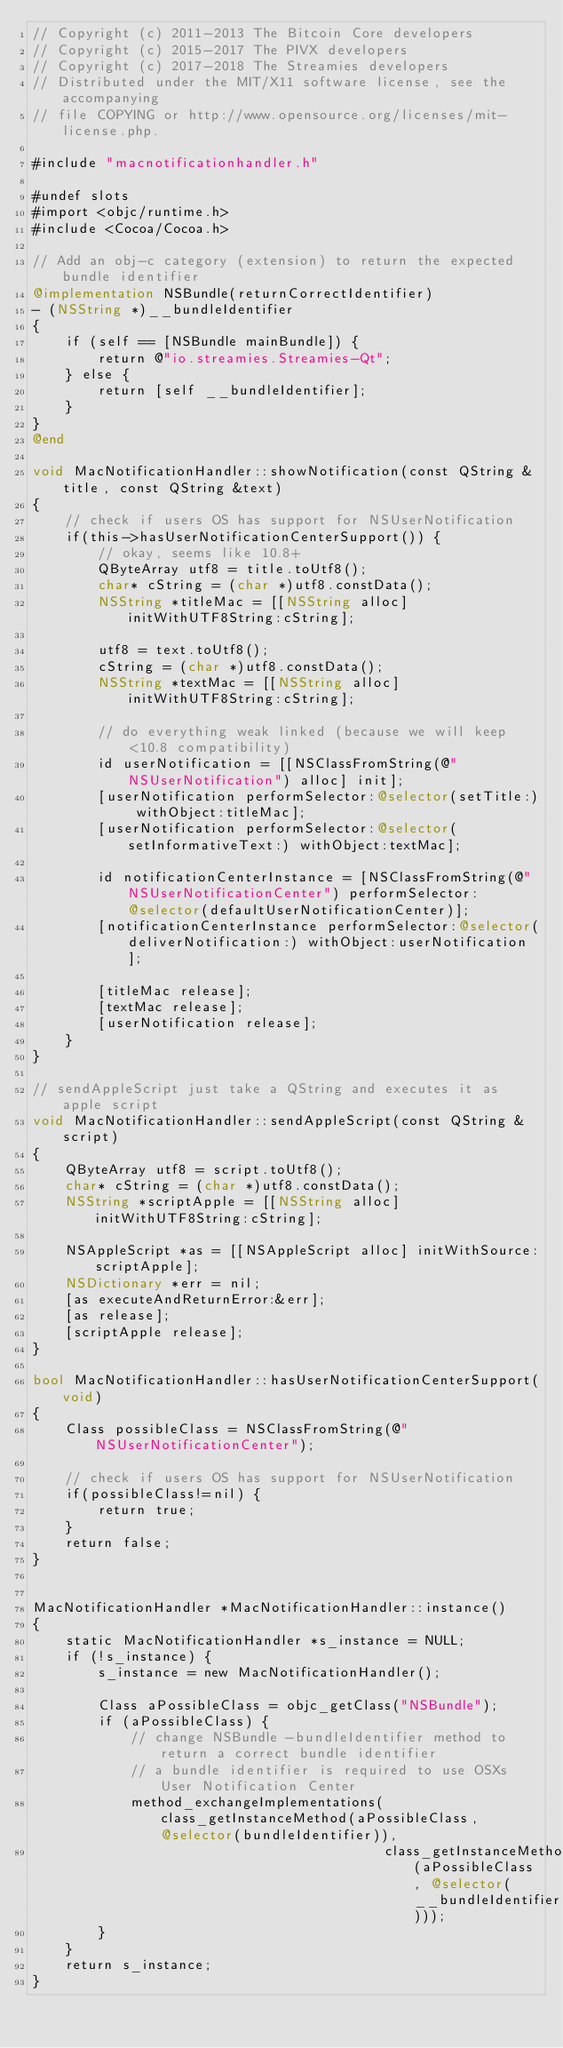<code> <loc_0><loc_0><loc_500><loc_500><_ObjectiveC_>// Copyright (c) 2011-2013 The Bitcoin Core developers
// Copyright (c) 2015-2017 The PIVX developers
// Copyright (c) 2017-2018 The Streamies developers
// Distributed under the MIT/X11 software license, see the accompanying
// file COPYING or http://www.opensource.org/licenses/mit-license.php.

#include "macnotificationhandler.h"

#undef slots
#import <objc/runtime.h>
#include <Cocoa/Cocoa.h>

// Add an obj-c category (extension) to return the expected bundle identifier
@implementation NSBundle(returnCorrectIdentifier)
- (NSString *)__bundleIdentifier
{
    if (self == [NSBundle mainBundle]) {
        return @"io.streamies.Streamies-Qt";
    } else {
        return [self __bundleIdentifier];
    }
}
@end

void MacNotificationHandler::showNotification(const QString &title, const QString &text)
{
    // check if users OS has support for NSUserNotification
    if(this->hasUserNotificationCenterSupport()) {
        // okay, seems like 10.8+
        QByteArray utf8 = title.toUtf8();
        char* cString = (char *)utf8.constData();
        NSString *titleMac = [[NSString alloc] initWithUTF8String:cString];

        utf8 = text.toUtf8();
        cString = (char *)utf8.constData();
        NSString *textMac = [[NSString alloc] initWithUTF8String:cString];

        // do everything weak linked (because we will keep <10.8 compatibility)
        id userNotification = [[NSClassFromString(@"NSUserNotification") alloc] init];
        [userNotification performSelector:@selector(setTitle:) withObject:titleMac];
        [userNotification performSelector:@selector(setInformativeText:) withObject:textMac];

        id notificationCenterInstance = [NSClassFromString(@"NSUserNotificationCenter") performSelector:@selector(defaultUserNotificationCenter)];
        [notificationCenterInstance performSelector:@selector(deliverNotification:) withObject:userNotification];

        [titleMac release];
        [textMac release];
        [userNotification release];
    }
}

// sendAppleScript just take a QString and executes it as apple script
void MacNotificationHandler::sendAppleScript(const QString &script)
{
    QByteArray utf8 = script.toUtf8();
    char* cString = (char *)utf8.constData();
    NSString *scriptApple = [[NSString alloc] initWithUTF8String:cString];

    NSAppleScript *as = [[NSAppleScript alloc] initWithSource:scriptApple];
    NSDictionary *err = nil;
    [as executeAndReturnError:&err];
    [as release];
    [scriptApple release];
}

bool MacNotificationHandler::hasUserNotificationCenterSupport(void)
{
    Class possibleClass = NSClassFromString(@"NSUserNotificationCenter");

    // check if users OS has support for NSUserNotification
    if(possibleClass!=nil) {
        return true;
    }
    return false;
}


MacNotificationHandler *MacNotificationHandler::instance()
{
    static MacNotificationHandler *s_instance = NULL;
    if (!s_instance) {
        s_instance = new MacNotificationHandler();
        
        Class aPossibleClass = objc_getClass("NSBundle");
        if (aPossibleClass) {
            // change NSBundle -bundleIdentifier method to return a correct bundle identifier
            // a bundle identifier is required to use OSXs User Notification Center
            method_exchangeImplementations(class_getInstanceMethod(aPossibleClass, @selector(bundleIdentifier)),
                                           class_getInstanceMethod(aPossibleClass, @selector(__bundleIdentifier)));
        }
    }
    return s_instance;
}
</code> 